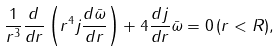Convert formula to latex. <formula><loc_0><loc_0><loc_500><loc_500>\frac { 1 } { r ^ { 3 } } \frac { d } { d r } \left ( r ^ { 4 } j \frac { d \bar { \omega } } { d r } \right ) + 4 \frac { d j } { d r } \bar { \omega } = 0 \, ( r < R ) ,</formula> 